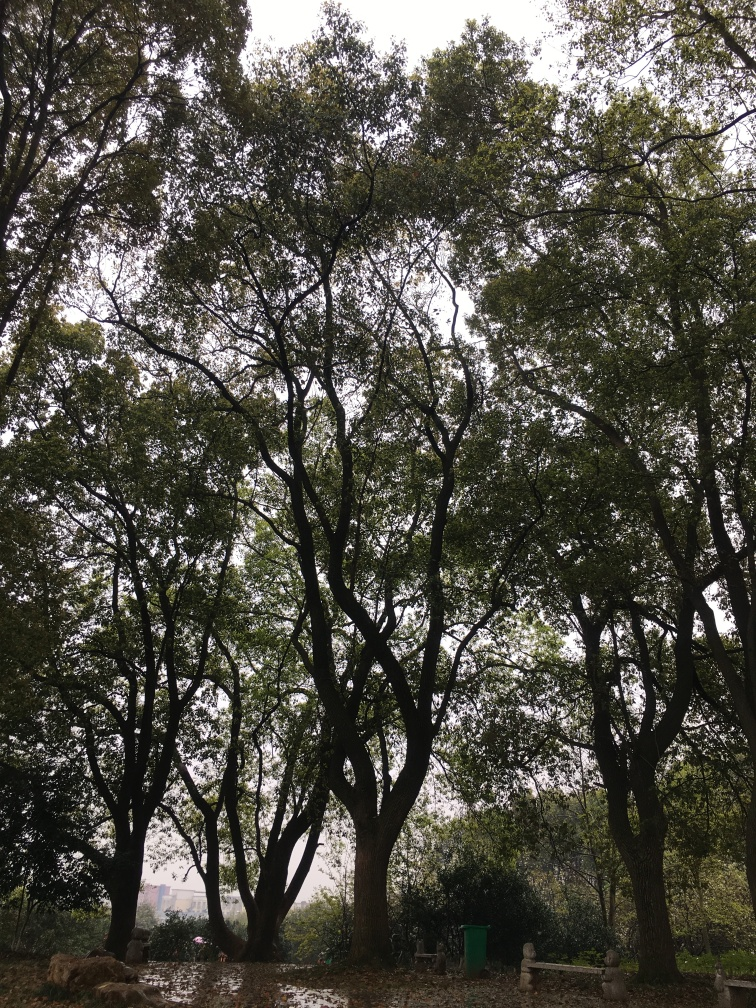What kind of weather might we be experiencing in this image? The sky is overcast, and the diffuse light suggests it's either a cloudy day or the photo was taken just before or after a rainfall. The ground appears slightly wet, supporting the idea that it might have recently rained. 